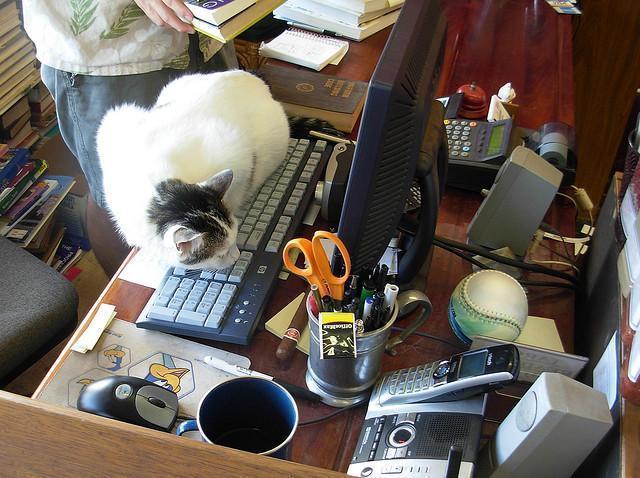What type tobacco product will the person who sits here smoke?
Answer the question by selecting the correct answer among the 4 following choices and explain your choice with a short sentence. The answer should be formatted with the following format: `Answer: choice
Rationale: rationale.`
Options: Snuff, cigar, hookah pipe, bong. Answer: cigar.
Rationale: As you can see near the keyboard a cigar is the only tobacco product shown. 